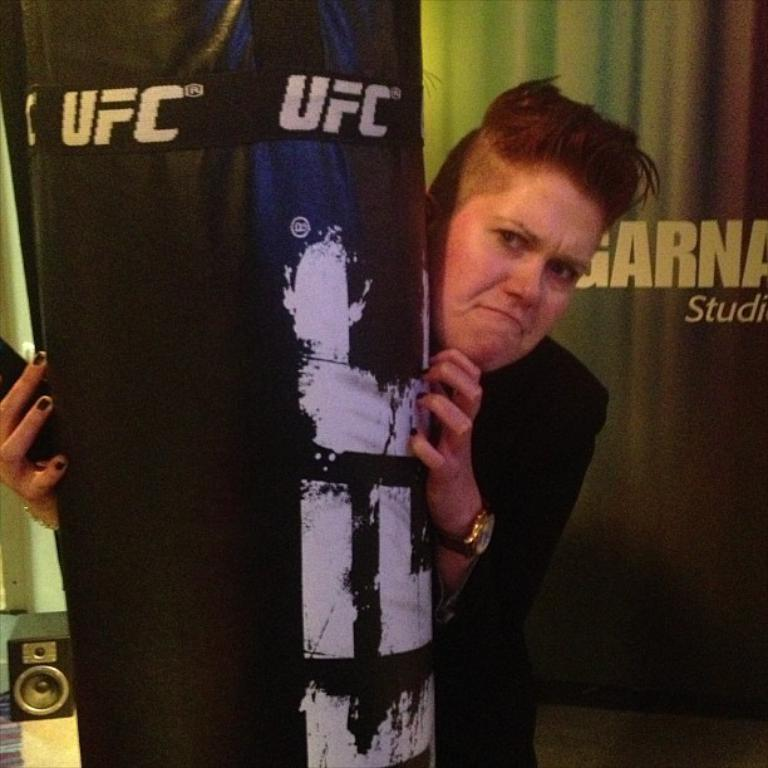<image>
Offer a succinct explanation of the picture presented. A woman hides behind a UFC punching bag. 